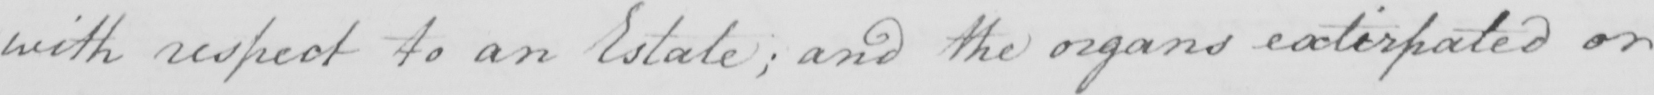What does this handwritten line say? with respect to an Estate ; and the organs extirpated or 